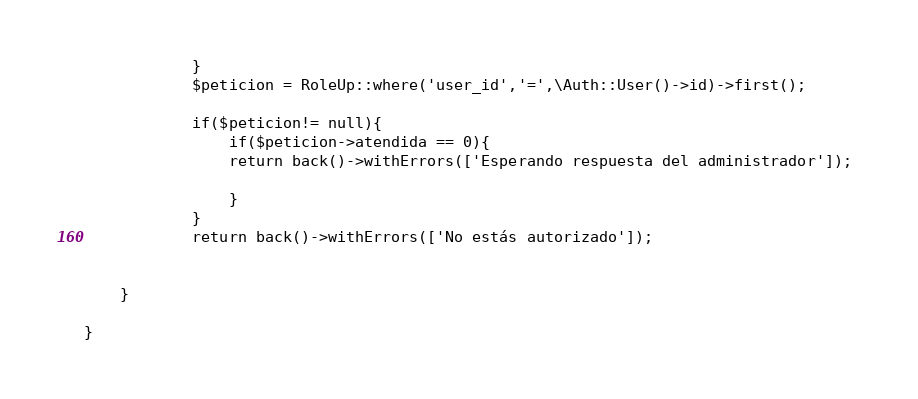<code> <loc_0><loc_0><loc_500><loc_500><_PHP_>            }
            $peticion = RoleUp::where('user_id','=',\Auth::User()->id)->first();
           
            if($peticion!= null){
                if($peticion->atendida == 0){
                return back()->withErrors(['Esperando respuesta del administrador']); 

                }
            }
            return back()->withErrors(['No estás autorizado']); 
           
       
    }
   
}
</code> 